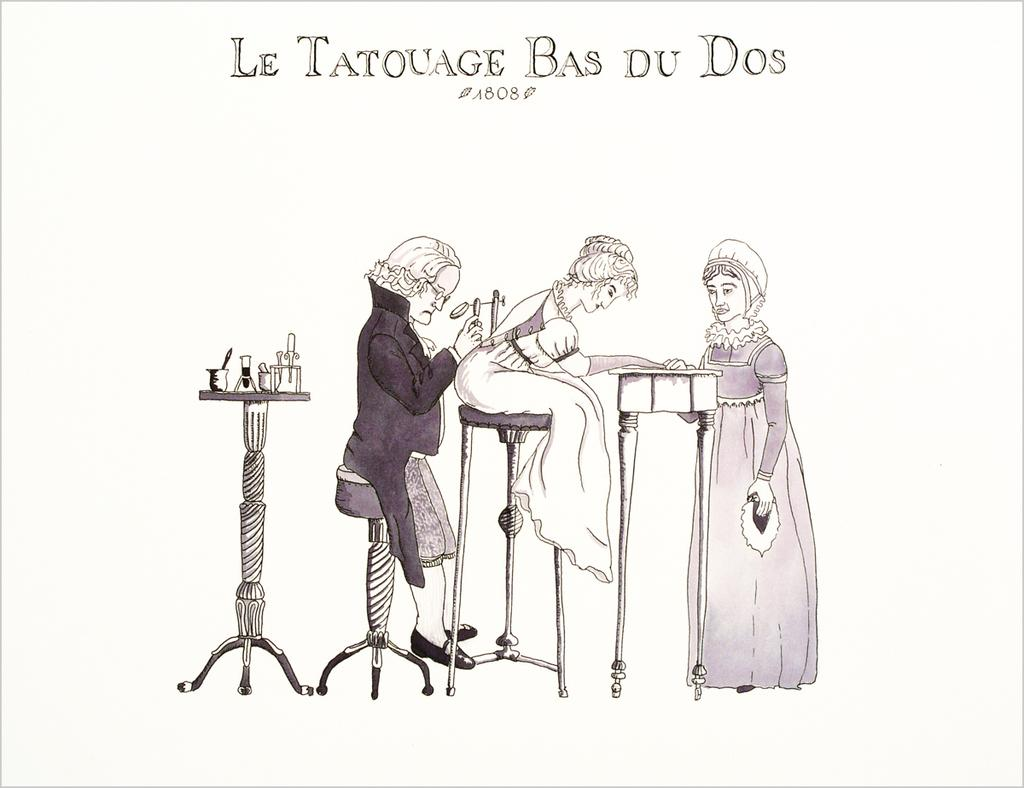What is the main object in the image? There is a measuring jug in the image. What else can be seen on the table? There are objects on the table. What are the people in the image doing? Two persons are sitting on stools, and a person is standing near a table. How many pies are being served on the table in the image? There is no mention of pies in the image; the objects on the table are not specified. What is the condition of the person's knee who is standing near the table? There is no information about the person's knee in the image; only their position near the table is mentioned. 